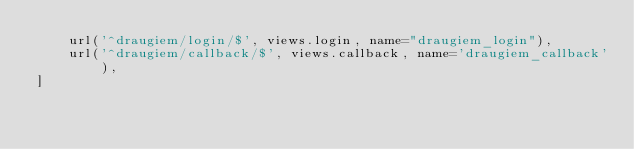<code> <loc_0><loc_0><loc_500><loc_500><_Python_>    url('^draugiem/login/$', views.login, name="draugiem_login"),
    url('^draugiem/callback/$', views.callback, name='draugiem_callback'),
]
</code> 